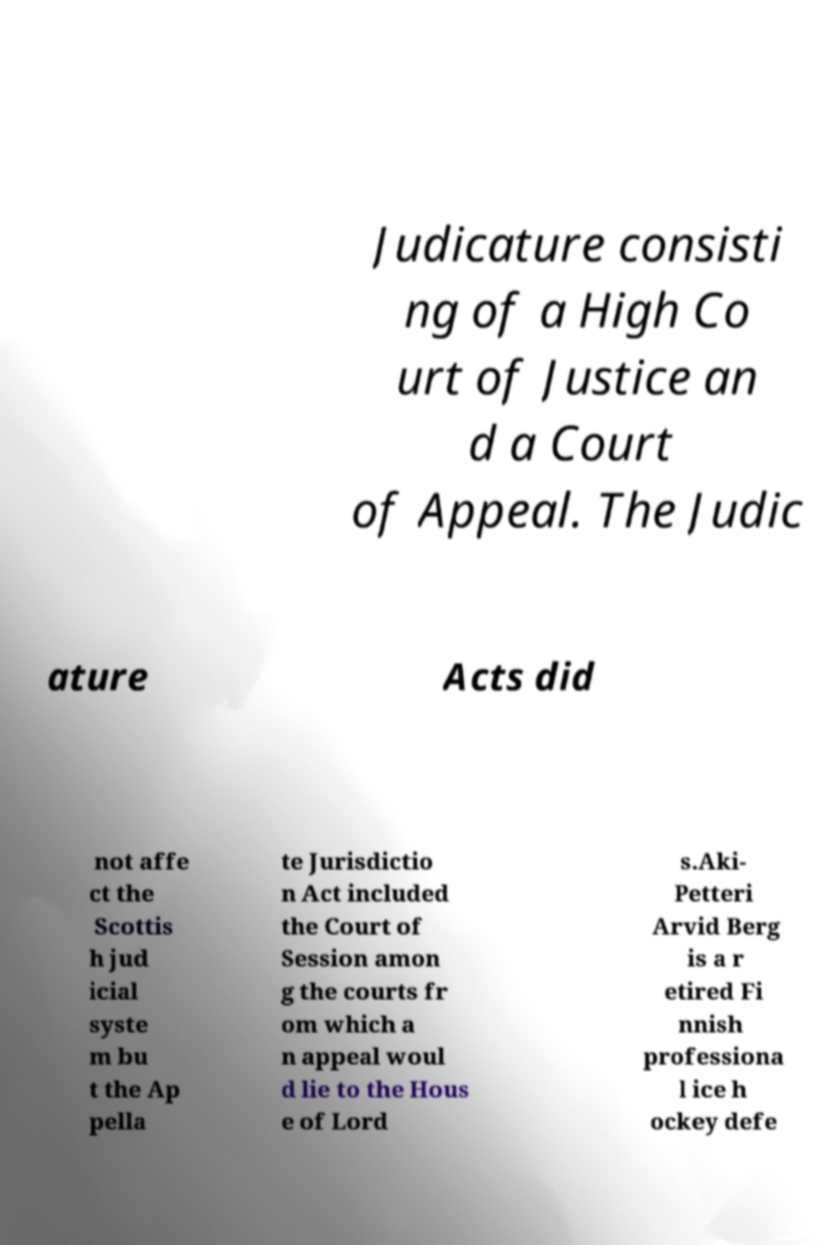Can you read and provide the text displayed in the image?This photo seems to have some interesting text. Can you extract and type it out for me? Judicature consisti ng of a High Co urt of Justice an d a Court of Appeal. The Judic ature Acts did not affe ct the Scottis h jud icial syste m bu t the Ap pella te Jurisdictio n Act included the Court of Session amon g the courts fr om which a n appeal woul d lie to the Hous e of Lord s.Aki- Petteri Arvid Berg is a r etired Fi nnish professiona l ice h ockey defe 